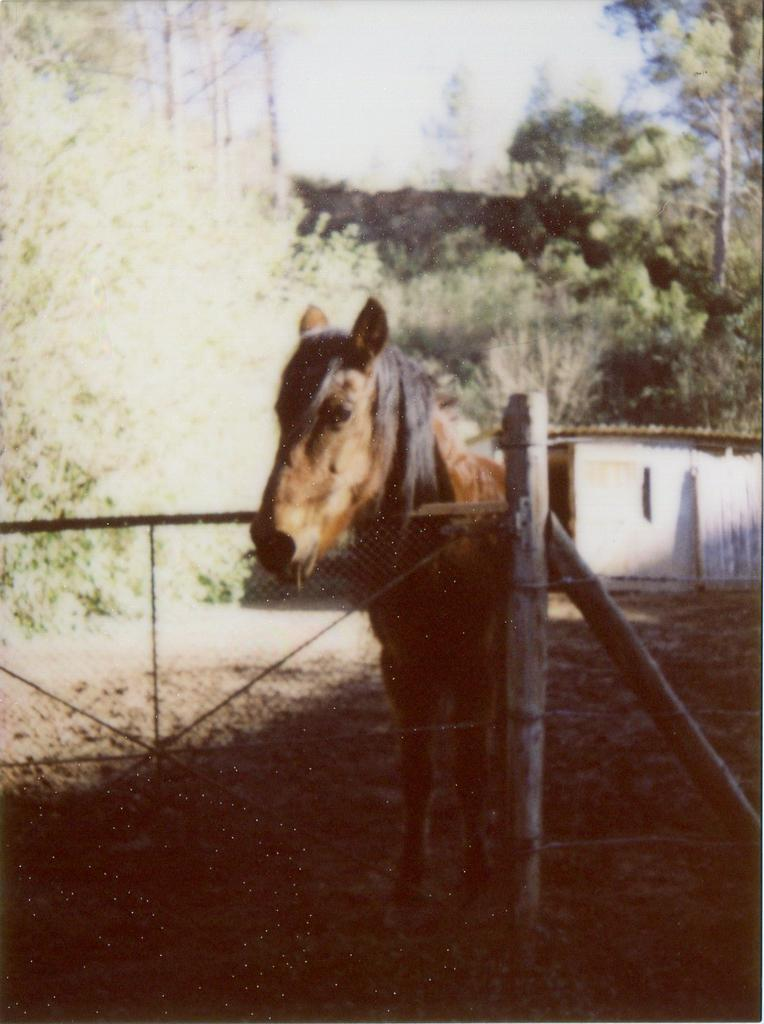What animal can be seen on the ground in the image? There is a horse on the ground in the image. What is in front of the horse? There is a fence with wooden sticks in front of the horse. What structure can be seen in the background of the image? There is a shed in the background of the image. What type of vegetation is visible in the background of the image? There are trees in the background of the image. Can you see the moon in the image? The moon is not visible in the image; it features a horse, a fence, a shed, and trees. What type of seed is being planted by the horse in the image? There is no seed or planting activity depicted in the image; it shows a horse, a fence, a shed, and trees. 